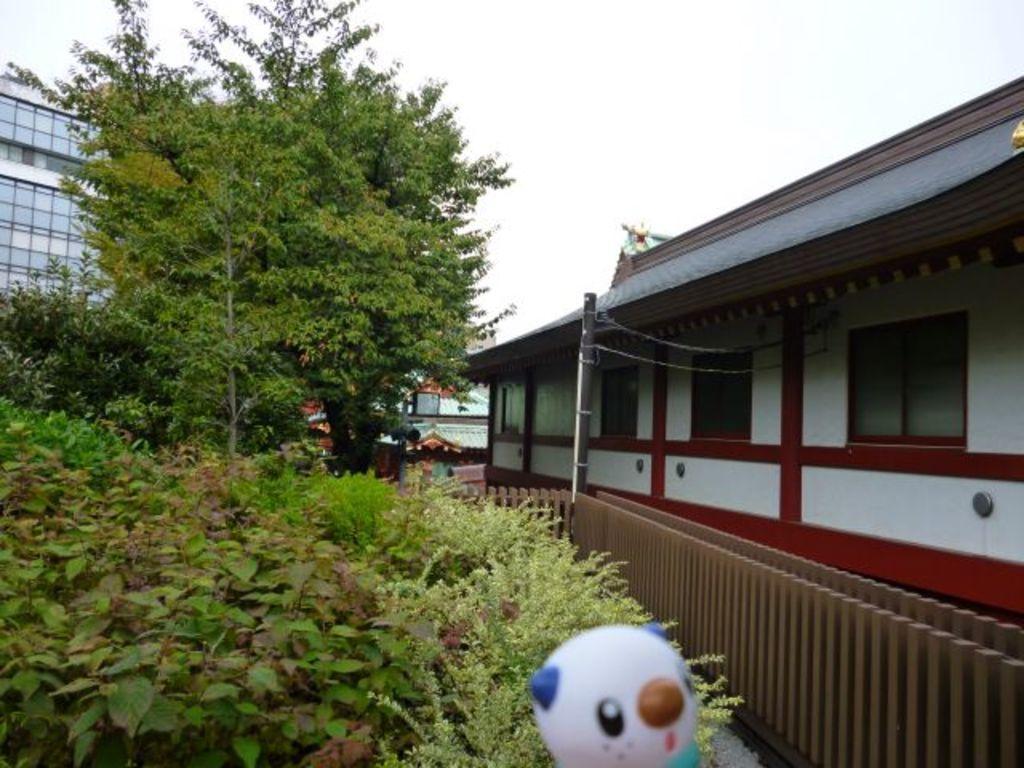How would you summarize this image in a sentence or two? At the bottom, we see a toy in white color. On the left side, we see the plants and the trees. On the right side, we see the railing, electric pole and a building in white and red color with s brown color roof. There are buildings in the background. At the top, we see the sky. 